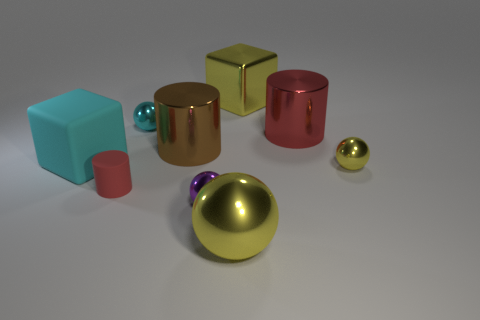The metal object that is the same color as the tiny rubber object is what shape?
Give a very brief answer. Cylinder. What is the material of the large object that is both in front of the big brown thing and behind the purple ball?
Your answer should be compact. Rubber. Are there fewer small gray metal balls than purple metallic objects?
Provide a succinct answer. Yes. There is a large cyan object; is it the same shape as the yellow metal object that is behind the cyan matte cube?
Your answer should be compact. Yes. There is a yellow sphere that is on the left side of the yellow shiny cube; does it have the same size as the small cyan sphere?
Make the answer very short. No. The cyan thing that is the same size as the red metallic thing is what shape?
Your answer should be very brief. Cube. Is the small yellow thing the same shape as the small red matte object?
Your response must be concise. No. How many other objects have the same shape as the small rubber object?
Keep it short and to the point. 2. How many small balls are behind the big red object?
Give a very brief answer. 1. Does the metallic ball that is behind the brown metallic cylinder have the same color as the large matte block?
Keep it short and to the point. Yes. 